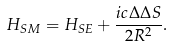<formula> <loc_0><loc_0><loc_500><loc_500>H _ { S M } = H _ { S E } + \frac { i c \Delta \Delta S } { 2 R ^ { 2 } } .</formula> 